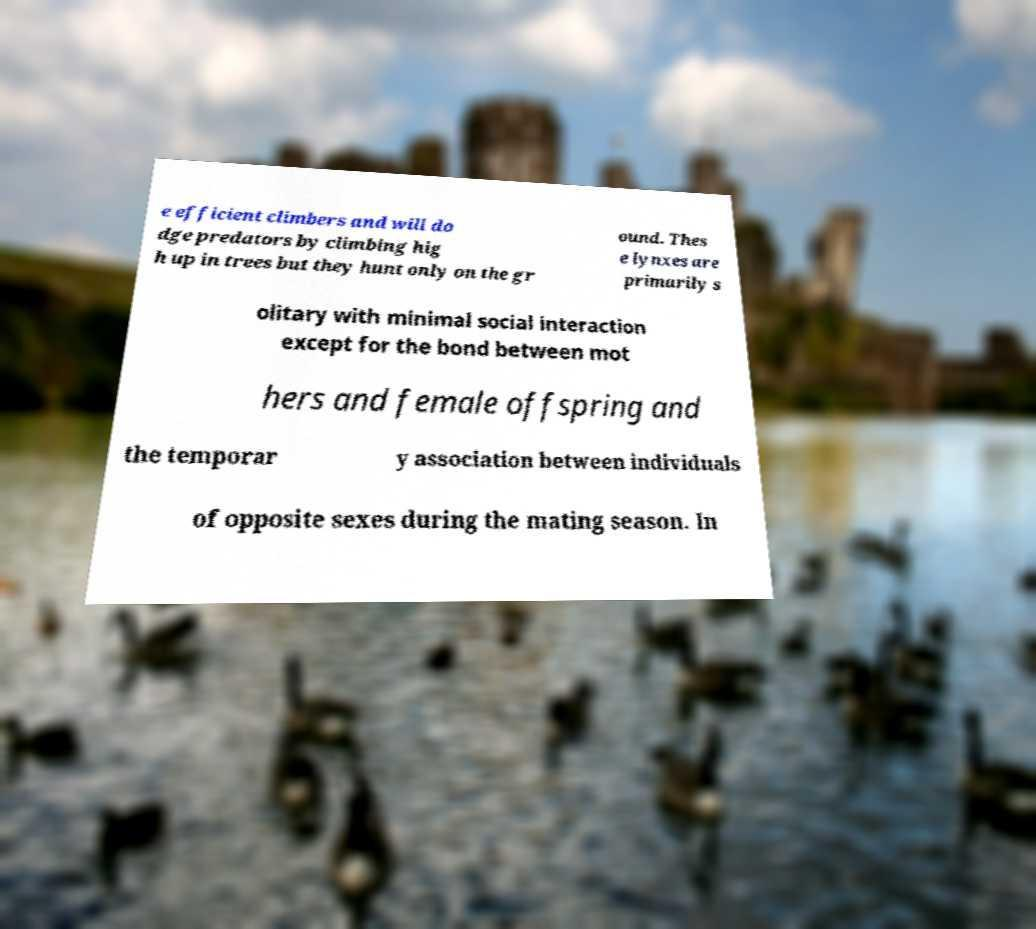Could you extract and type out the text from this image? e efficient climbers and will do dge predators by climbing hig h up in trees but they hunt only on the gr ound. Thes e lynxes are primarily s olitary with minimal social interaction except for the bond between mot hers and female offspring and the temporar y association between individuals of opposite sexes during the mating season. In 